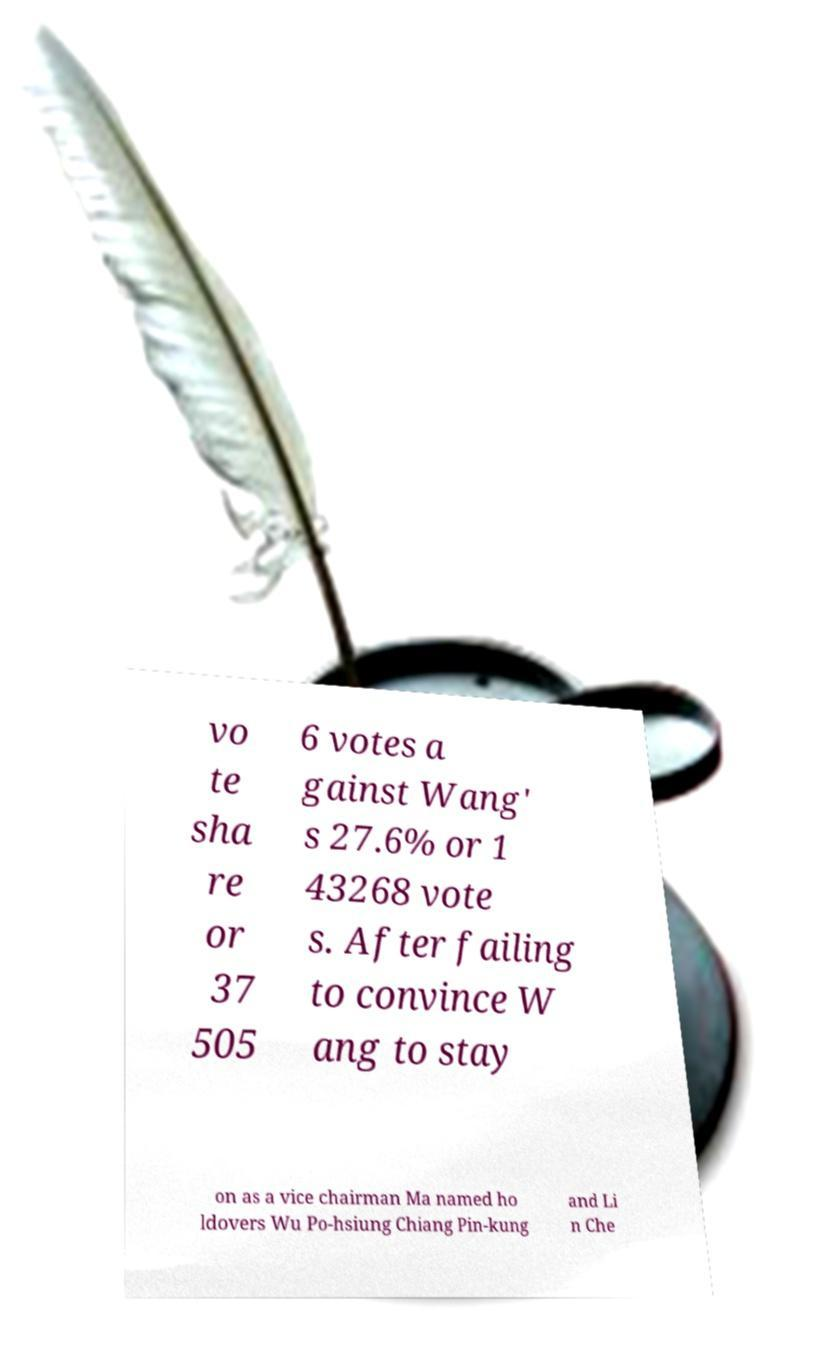Could you extract and type out the text from this image? vo te sha re or 37 505 6 votes a gainst Wang' s 27.6% or 1 43268 vote s. After failing to convince W ang to stay on as a vice chairman Ma named ho ldovers Wu Po-hsiung Chiang Pin-kung and Li n Che 